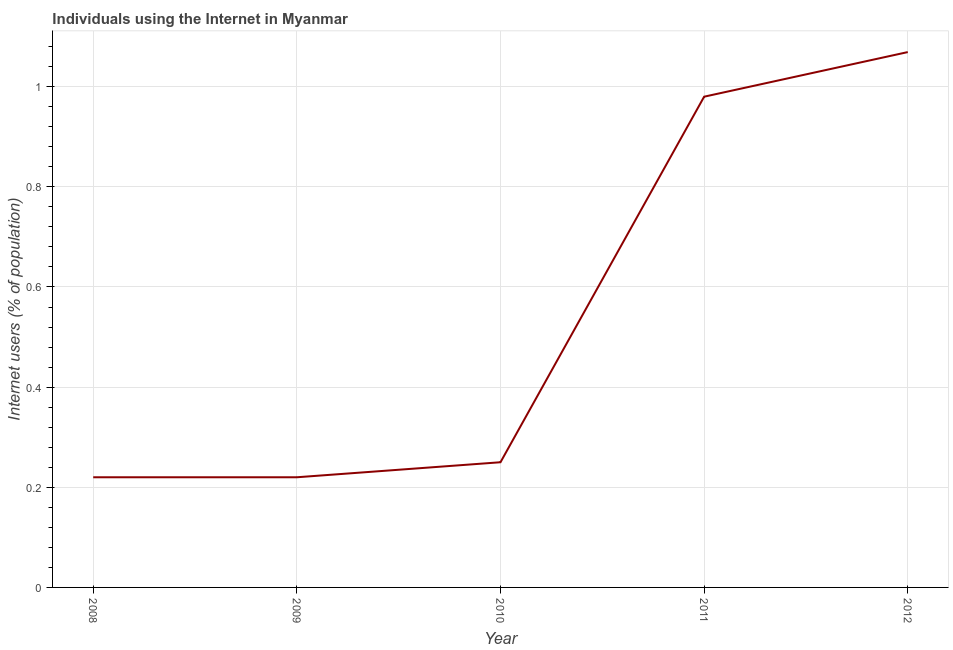What is the number of internet users in 2009?
Your response must be concise. 0.22. Across all years, what is the maximum number of internet users?
Provide a short and direct response. 1.07. Across all years, what is the minimum number of internet users?
Your answer should be compact. 0.22. In which year was the number of internet users minimum?
Provide a short and direct response. 2008. What is the sum of the number of internet users?
Provide a succinct answer. 2.74. What is the difference between the number of internet users in 2008 and 2009?
Keep it short and to the point. 0. What is the average number of internet users per year?
Offer a very short reply. 0.55. In how many years, is the number of internet users greater than 0.24000000000000002 %?
Provide a short and direct response. 3. Do a majority of the years between 2011 and 2008 (inclusive) have number of internet users greater than 0.44 %?
Your answer should be very brief. Yes. What is the ratio of the number of internet users in 2009 to that in 2012?
Provide a succinct answer. 0.21. What is the difference between the highest and the second highest number of internet users?
Offer a very short reply. 0.09. What is the difference between the highest and the lowest number of internet users?
Keep it short and to the point. 0.85. In how many years, is the number of internet users greater than the average number of internet users taken over all years?
Your answer should be compact. 2. Does the number of internet users monotonically increase over the years?
Keep it short and to the point. No. How many lines are there?
Give a very brief answer. 1. How many years are there in the graph?
Your response must be concise. 5. What is the difference between two consecutive major ticks on the Y-axis?
Your answer should be very brief. 0.2. Are the values on the major ticks of Y-axis written in scientific E-notation?
Give a very brief answer. No. Does the graph contain grids?
Your answer should be compact. Yes. What is the title of the graph?
Your response must be concise. Individuals using the Internet in Myanmar. What is the label or title of the Y-axis?
Make the answer very short. Internet users (% of population). What is the Internet users (% of population) in 2008?
Give a very brief answer. 0.22. What is the Internet users (% of population) in 2009?
Your answer should be very brief. 0.22. What is the Internet users (% of population) of 2010?
Make the answer very short. 0.25. What is the Internet users (% of population) of 2011?
Provide a short and direct response. 0.98. What is the Internet users (% of population) of 2012?
Make the answer very short. 1.07. What is the difference between the Internet users (% of population) in 2008 and 2010?
Your answer should be very brief. -0.03. What is the difference between the Internet users (% of population) in 2008 and 2011?
Provide a short and direct response. -0.76. What is the difference between the Internet users (% of population) in 2008 and 2012?
Give a very brief answer. -0.85. What is the difference between the Internet users (% of population) in 2009 and 2010?
Provide a succinct answer. -0.03. What is the difference between the Internet users (% of population) in 2009 and 2011?
Provide a short and direct response. -0.76. What is the difference between the Internet users (% of population) in 2009 and 2012?
Offer a very short reply. -0.85. What is the difference between the Internet users (% of population) in 2010 and 2011?
Your answer should be compact. -0.73. What is the difference between the Internet users (% of population) in 2010 and 2012?
Provide a succinct answer. -0.82. What is the difference between the Internet users (% of population) in 2011 and 2012?
Ensure brevity in your answer.  -0.09. What is the ratio of the Internet users (% of population) in 2008 to that in 2009?
Offer a terse response. 1. What is the ratio of the Internet users (% of population) in 2008 to that in 2011?
Offer a terse response. 0.22. What is the ratio of the Internet users (% of population) in 2008 to that in 2012?
Offer a very short reply. 0.21. What is the ratio of the Internet users (% of population) in 2009 to that in 2010?
Your answer should be compact. 0.88. What is the ratio of the Internet users (% of population) in 2009 to that in 2011?
Offer a very short reply. 0.22. What is the ratio of the Internet users (% of population) in 2009 to that in 2012?
Offer a very short reply. 0.21. What is the ratio of the Internet users (% of population) in 2010 to that in 2011?
Offer a very short reply. 0.26. What is the ratio of the Internet users (% of population) in 2010 to that in 2012?
Provide a succinct answer. 0.23. What is the ratio of the Internet users (% of population) in 2011 to that in 2012?
Offer a terse response. 0.92. 